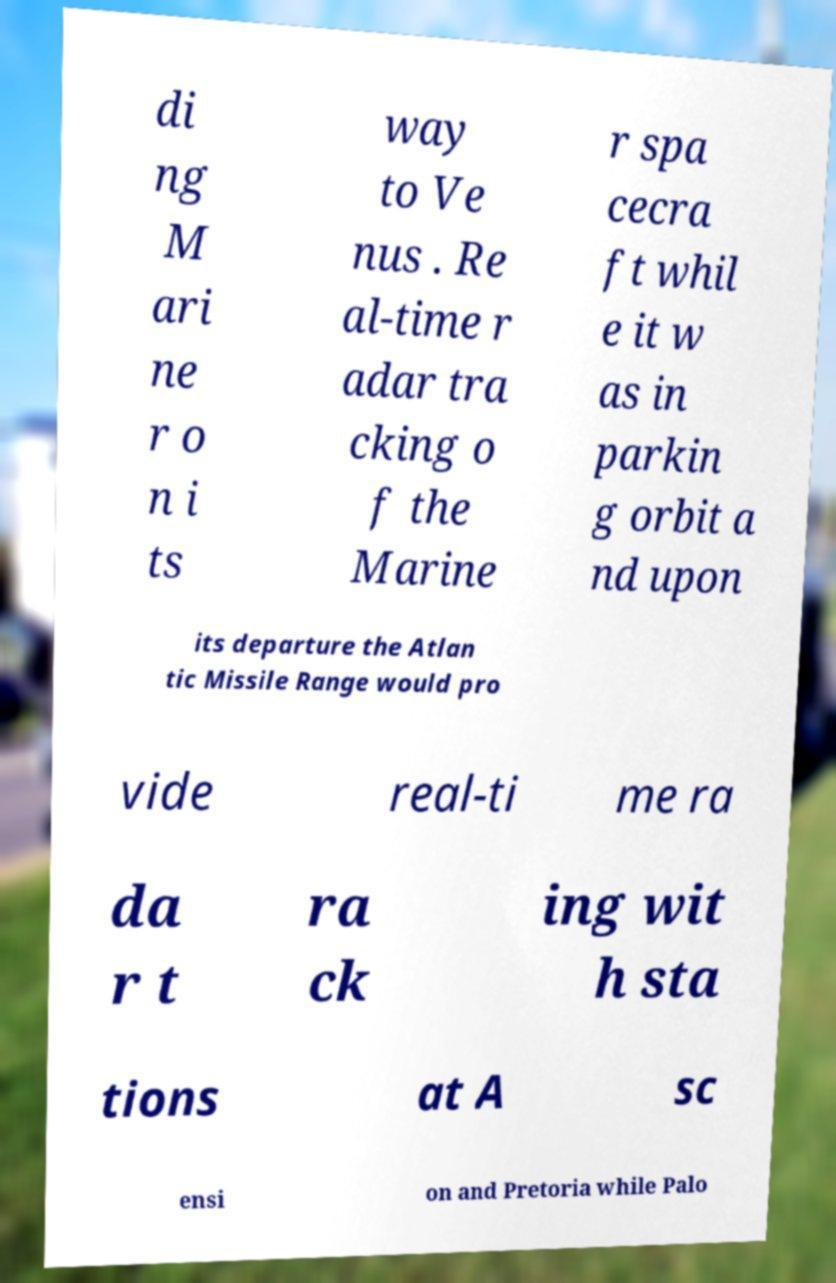Could you extract and type out the text from this image? di ng M ari ne r o n i ts way to Ve nus . Re al-time r adar tra cking o f the Marine r spa cecra ft whil e it w as in parkin g orbit a nd upon its departure the Atlan tic Missile Range would pro vide real-ti me ra da r t ra ck ing wit h sta tions at A sc ensi on and Pretoria while Palo 